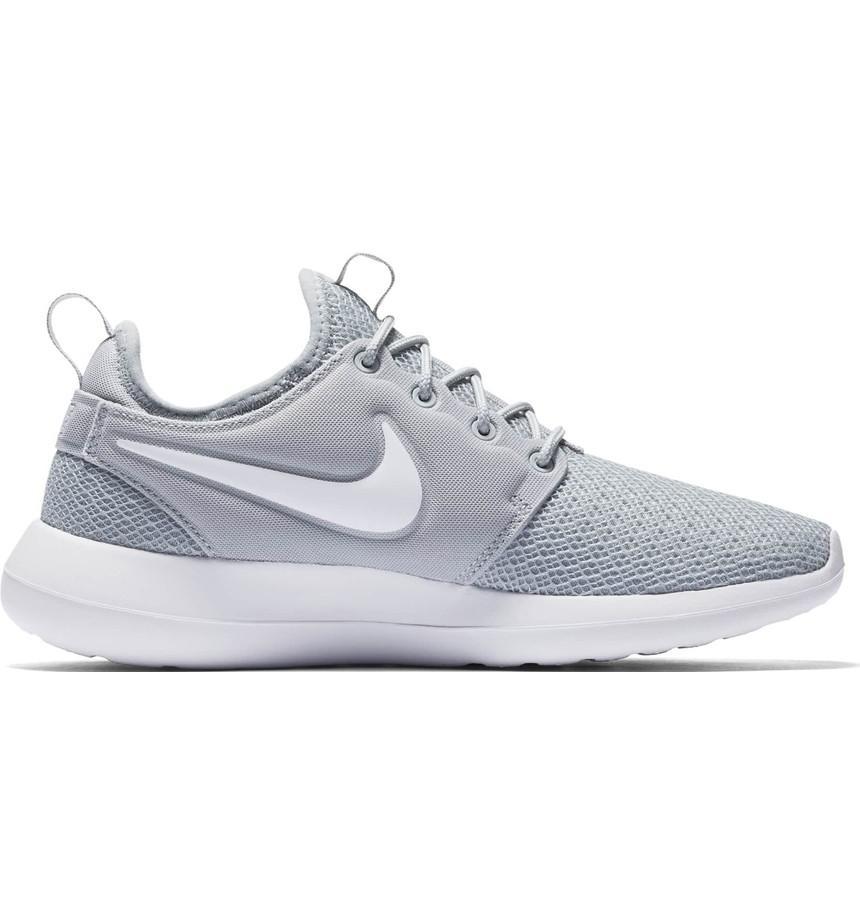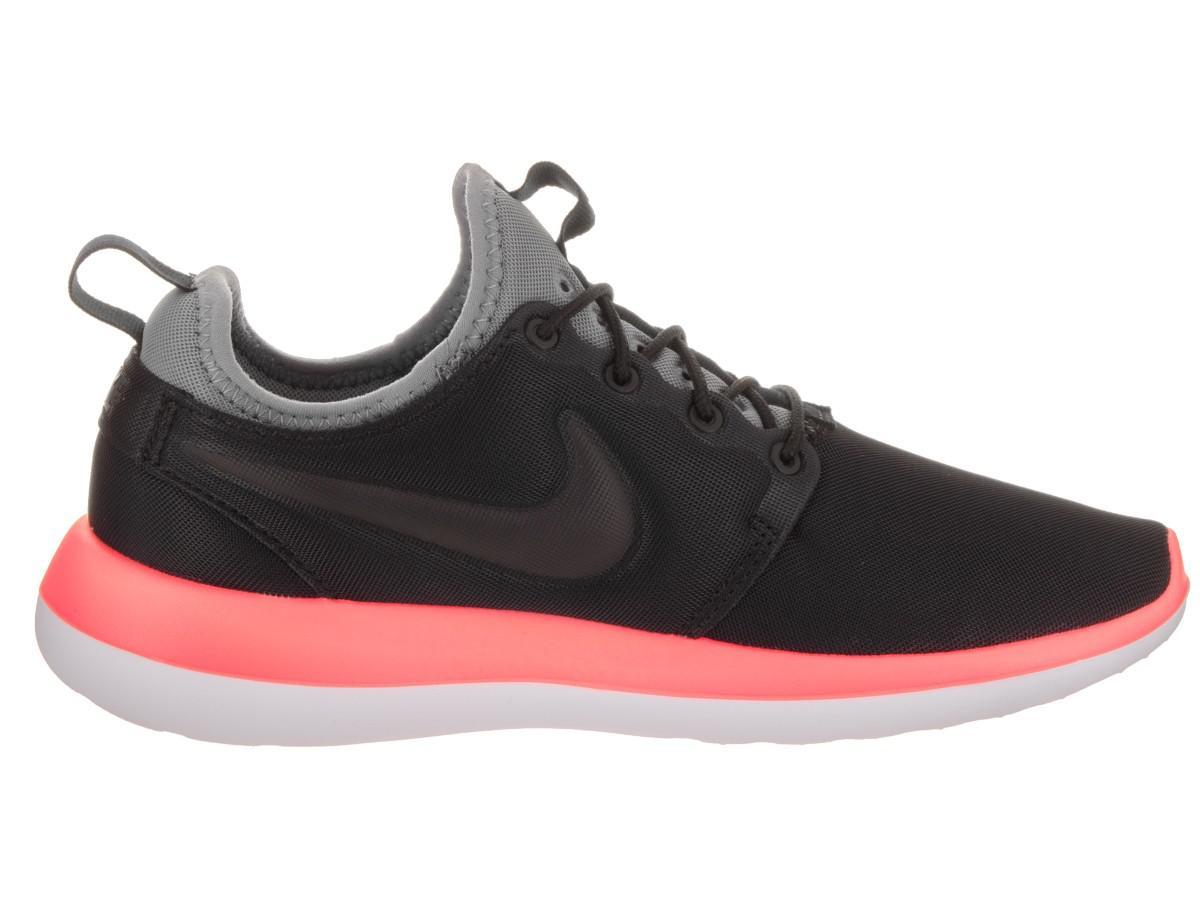The first image is the image on the left, the second image is the image on the right. Given the left and right images, does the statement "One of the shoes has a coral pink and white sole." hold true? Answer yes or no. Yes. The first image is the image on the left, the second image is the image on the right. Assess this claim about the two images: "There are two shoes, both pointing in the same direction". Correct or not? Answer yes or no. Yes. 